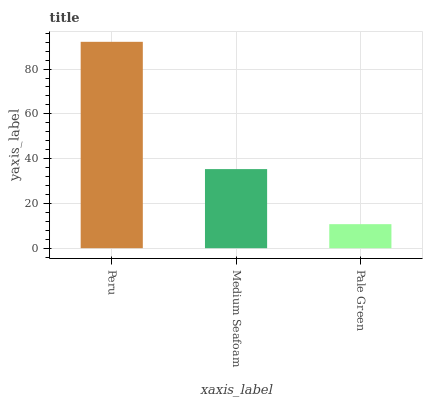Is Pale Green the minimum?
Answer yes or no. Yes. Is Peru the maximum?
Answer yes or no. Yes. Is Medium Seafoam the minimum?
Answer yes or no. No. Is Medium Seafoam the maximum?
Answer yes or no. No. Is Peru greater than Medium Seafoam?
Answer yes or no. Yes. Is Medium Seafoam less than Peru?
Answer yes or no. Yes. Is Medium Seafoam greater than Peru?
Answer yes or no. No. Is Peru less than Medium Seafoam?
Answer yes or no. No. Is Medium Seafoam the high median?
Answer yes or no. Yes. Is Medium Seafoam the low median?
Answer yes or no. Yes. Is Pale Green the high median?
Answer yes or no. No. Is Peru the low median?
Answer yes or no. No. 